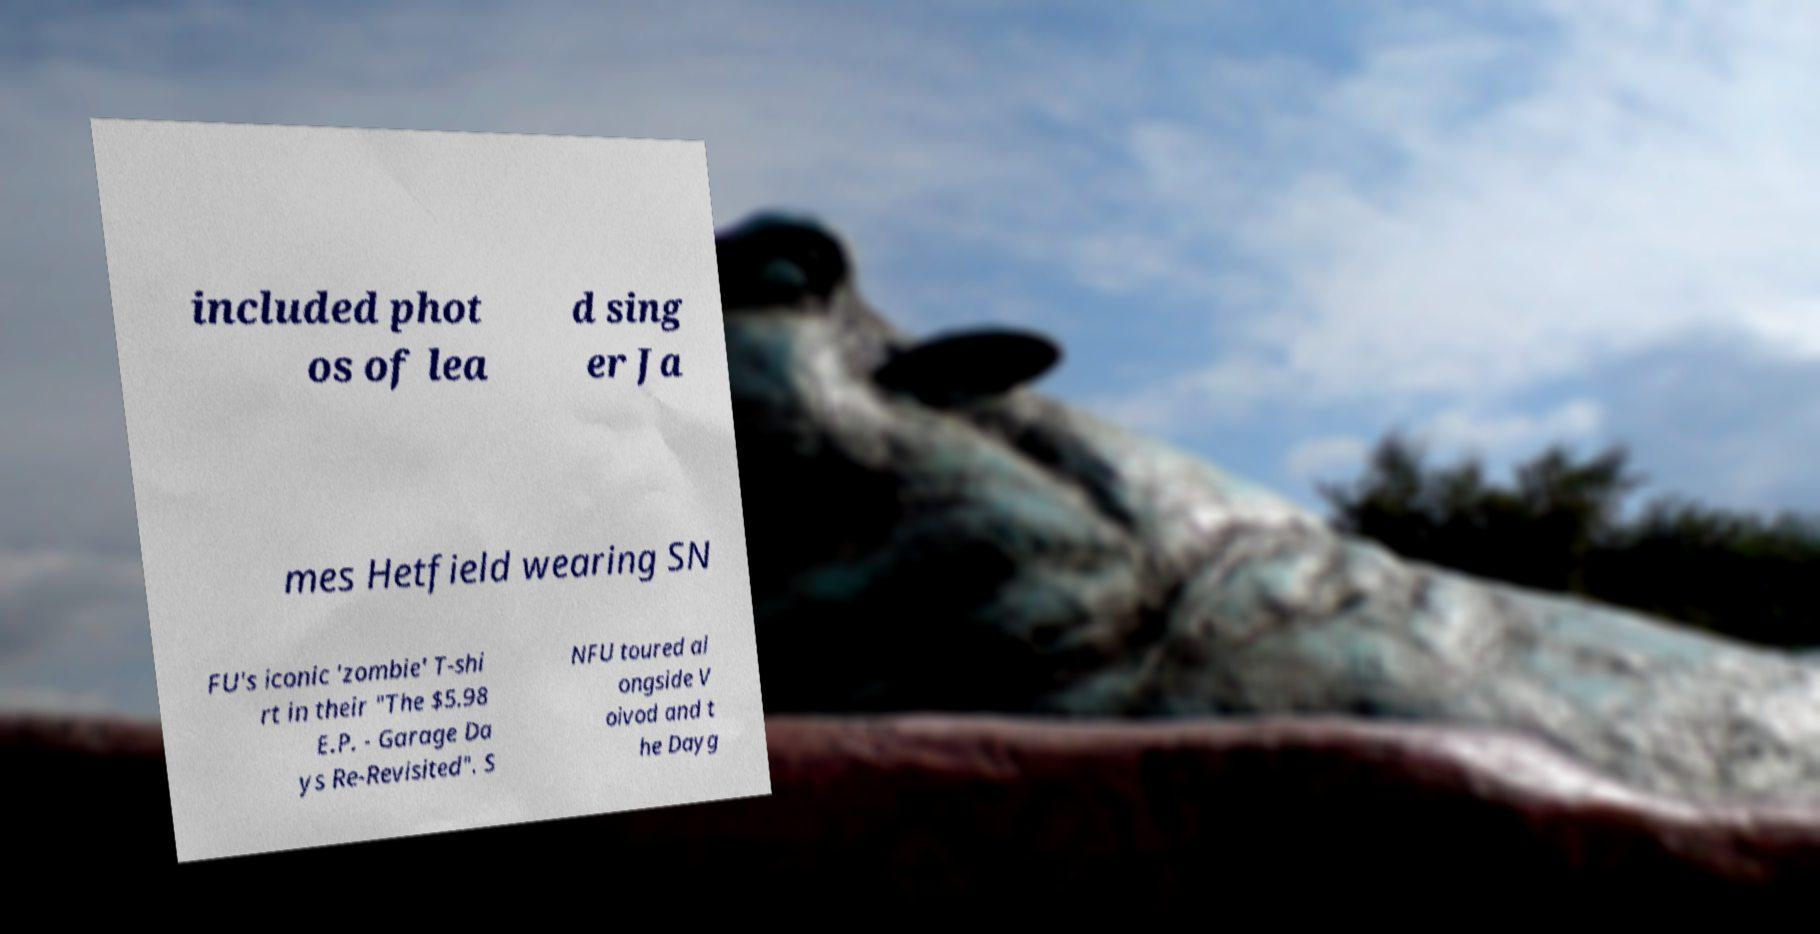Please read and relay the text visible in this image. What does it say? included phot os of lea d sing er Ja mes Hetfield wearing SN FU's iconic 'zombie' T-shi rt in their "The $5.98 E.P. - Garage Da ys Re-Revisited". S NFU toured al ongside V oivod and t he Dayg 